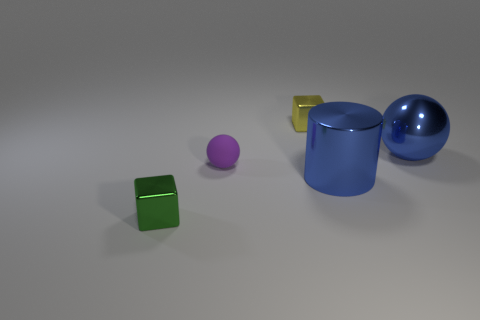Is there any other thing that is made of the same material as the small purple object?
Your answer should be compact. No. What material is the object that is both right of the green metallic block and left of the small yellow metallic object?
Your response must be concise. Rubber. There is a yellow metal thing that is the same shape as the green thing; what is its size?
Your response must be concise. Small. Does the blue ball have the same size as the object that is behind the large shiny ball?
Keep it short and to the point. No. What shape is the thing that is the same color as the metallic cylinder?
Provide a succinct answer. Sphere. What number of cylinders are the same size as the purple sphere?
Make the answer very short. 0. How many large metallic balls are on the left side of the tiny green block?
Give a very brief answer. 0. What material is the ball that is on the left side of the sphere right of the yellow object?
Make the answer very short. Rubber. Is there a big ball that has the same color as the metal cylinder?
Give a very brief answer. Yes. What size is the yellow thing that is the same material as the small green thing?
Provide a short and direct response. Small. 